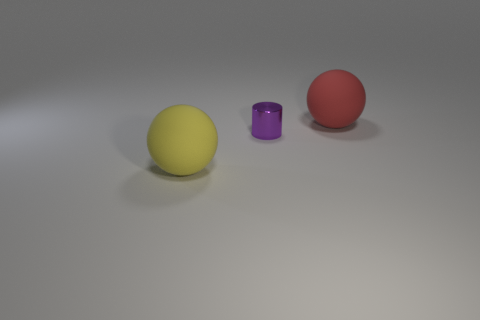Is the lighting in the image coming from a specific direction? Based on the shadows and highlights on the objects, it appears that the lighting is coming from the top left direction, casting subtle shadows on the right side of the objects. 